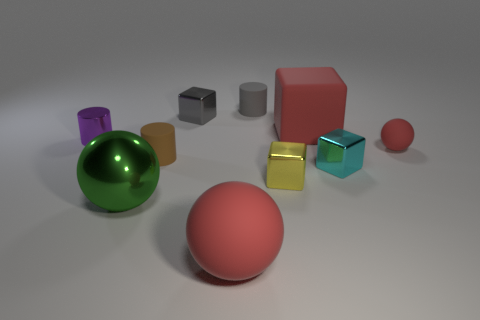Subtract all cylinders. How many objects are left? 7 Subtract 0 gray spheres. How many objects are left? 10 Subtract all tiny red metallic cylinders. Subtract all tiny brown rubber cylinders. How many objects are left? 9 Add 1 small red objects. How many small red objects are left? 2 Add 1 small blocks. How many small blocks exist? 4 